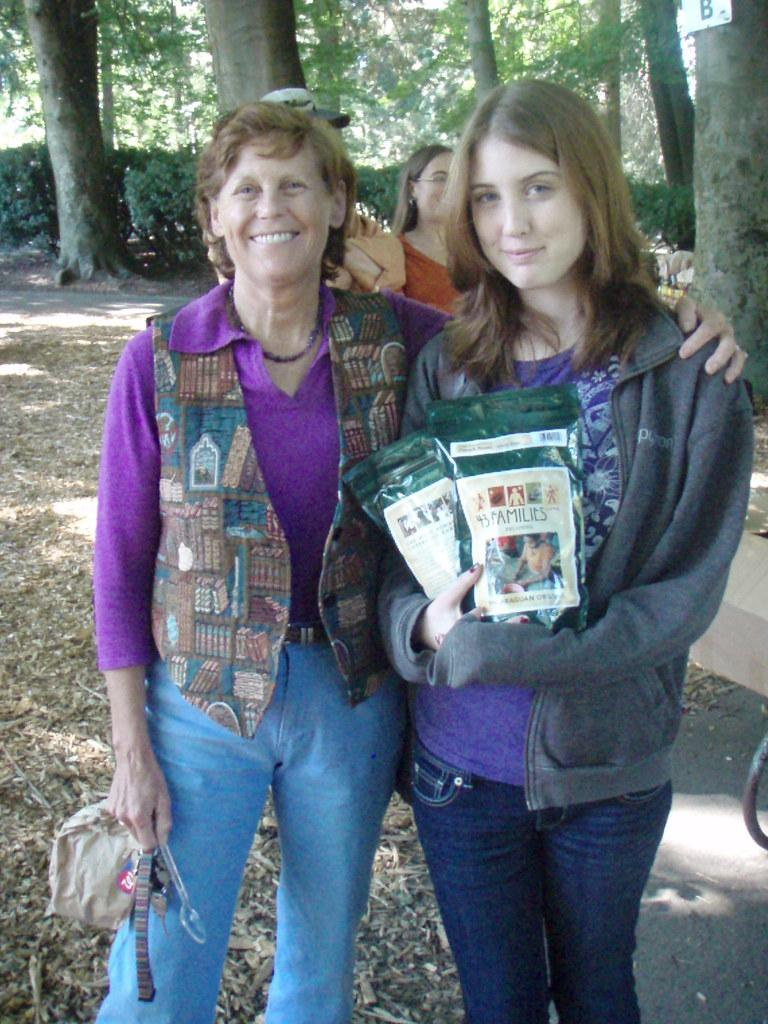Who is present in the image? There are women in the image. What are the women doing in the image? The women are standing and posing for a photograph. What can be seen in the background of the image? There are trees in the background of the image. What is the force applied by the women in the image? There is no information about force in the image, as it only shows women standing and posing for a photograph. 